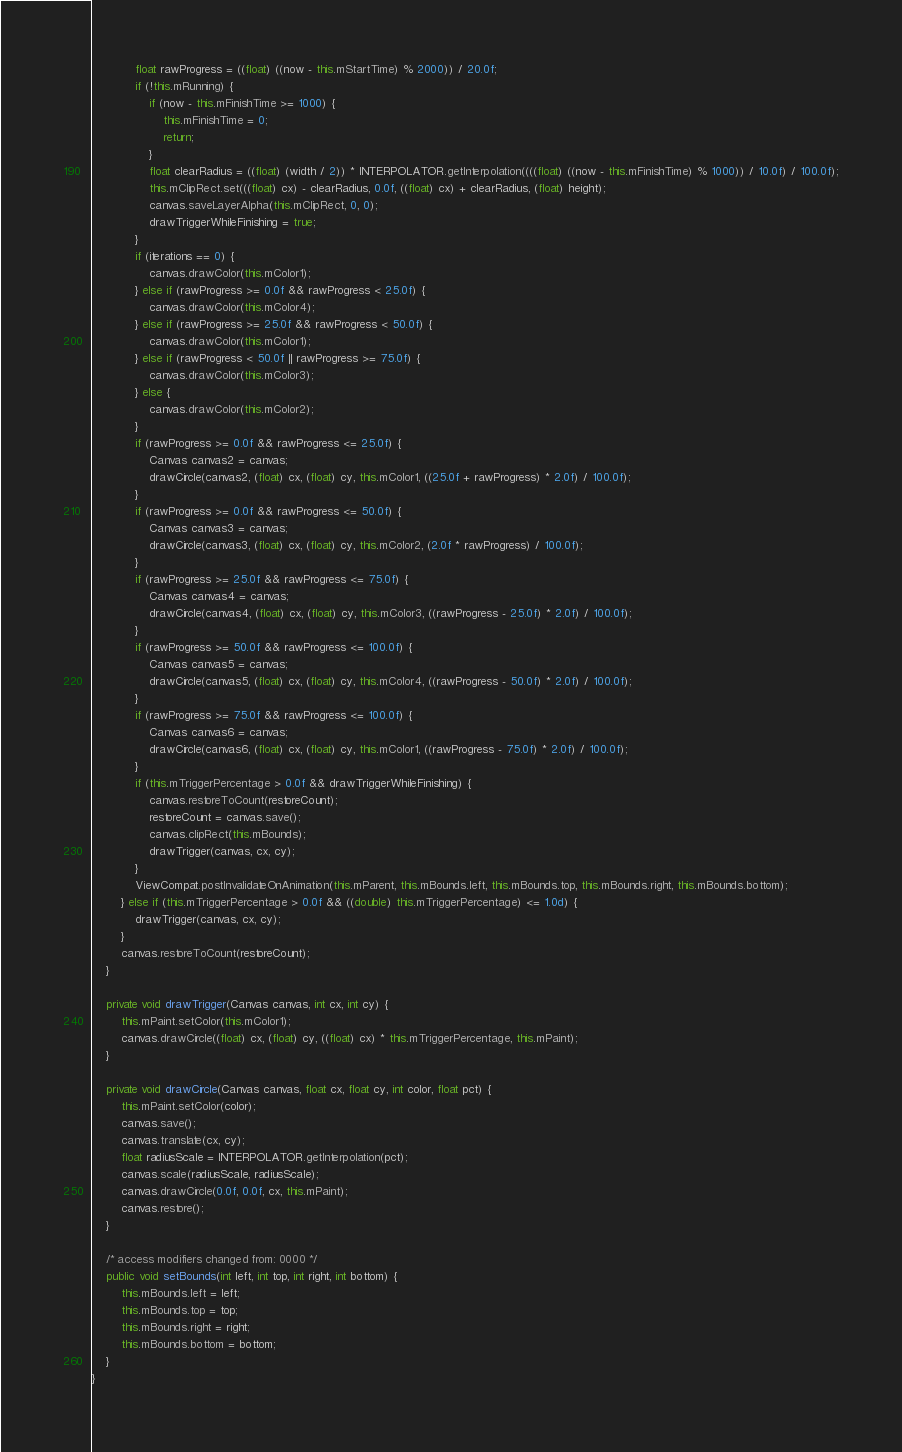Convert code to text. <code><loc_0><loc_0><loc_500><loc_500><_Java_>            float rawProgress = ((float) ((now - this.mStartTime) % 2000)) / 20.0f;
            if (!this.mRunning) {
                if (now - this.mFinishTime >= 1000) {
                    this.mFinishTime = 0;
                    return;
                }
                float clearRadius = ((float) (width / 2)) * INTERPOLATOR.getInterpolation((((float) ((now - this.mFinishTime) % 1000)) / 10.0f) / 100.0f);
                this.mClipRect.set(((float) cx) - clearRadius, 0.0f, ((float) cx) + clearRadius, (float) height);
                canvas.saveLayerAlpha(this.mClipRect, 0, 0);
                drawTriggerWhileFinishing = true;
            }
            if (iterations == 0) {
                canvas.drawColor(this.mColor1);
            } else if (rawProgress >= 0.0f && rawProgress < 25.0f) {
                canvas.drawColor(this.mColor4);
            } else if (rawProgress >= 25.0f && rawProgress < 50.0f) {
                canvas.drawColor(this.mColor1);
            } else if (rawProgress < 50.0f || rawProgress >= 75.0f) {
                canvas.drawColor(this.mColor3);
            } else {
                canvas.drawColor(this.mColor2);
            }
            if (rawProgress >= 0.0f && rawProgress <= 25.0f) {
                Canvas canvas2 = canvas;
                drawCircle(canvas2, (float) cx, (float) cy, this.mColor1, ((25.0f + rawProgress) * 2.0f) / 100.0f);
            }
            if (rawProgress >= 0.0f && rawProgress <= 50.0f) {
                Canvas canvas3 = canvas;
                drawCircle(canvas3, (float) cx, (float) cy, this.mColor2, (2.0f * rawProgress) / 100.0f);
            }
            if (rawProgress >= 25.0f && rawProgress <= 75.0f) {
                Canvas canvas4 = canvas;
                drawCircle(canvas4, (float) cx, (float) cy, this.mColor3, ((rawProgress - 25.0f) * 2.0f) / 100.0f);
            }
            if (rawProgress >= 50.0f && rawProgress <= 100.0f) {
                Canvas canvas5 = canvas;
                drawCircle(canvas5, (float) cx, (float) cy, this.mColor4, ((rawProgress - 50.0f) * 2.0f) / 100.0f);
            }
            if (rawProgress >= 75.0f && rawProgress <= 100.0f) {
                Canvas canvas6 = canvas;
                drawCircle(canvas6, (float) cx, (float) cy, this.mColor1, ((rawProgress - 75.0f) * 2.0f) / 100.0f);
            }
            if (this.mTriggerPercentage > 0.0f && drawTriggerWhileFinishing) {
                canvas.restoreToCount(restoreCount);
                restoreCount = canvas.save();
                canvas.clipRect(this.mBounds);
                drawTrigger(canvas, cx, cy);
            }
            ViewCompat.postInvalidateOnAnimation(this.mParent, this.mBounds.left, this.mBounds.top, this.mBounds.right, this.mBounds.bottom);
        } else if (this.mTriggerPercentage > 0.0f && ((double) this.mTriggerPercentage) <= 1.0d) {
            drawTrigger(canvas, cx, cy);
        }
        canvas.restoreToCount(restoreCount);
    }

    private void drawTrigger(Canvas canvas, int cx, int cy) {
        this.mPaint.setColor(this.mColor1);
        canvas.drawCircle((float) cx, (float) cy, ((float) cx) * this.mTriggerPercentage, this.mPaint);
    }

    private void drawCircle(Canvas canvas, float cx, float cy, int color, float pct) {
        this.mPaint.setColor(color);
        canvas.save();
        canvas.translate(cx, cy);
        float radiusScale = INTERPOLATOR.getInterpolation(pct);
        canvas.scale(radiusScale, radiusScale);
        canvas.drawCircle(0.0f, 0.0f, cx, this.mPaint);
        canvas.restore();
    }

    /* access modifiers changed from: 0000 */
    public void setBounds(int left, int top, int right, int bottom) {
        this.mBounds.left = left;
        this.mBounds.top = top;
        this.mBounds.right = right;
        this.mBounds.bottom = bottom;
    }
}
</code> 